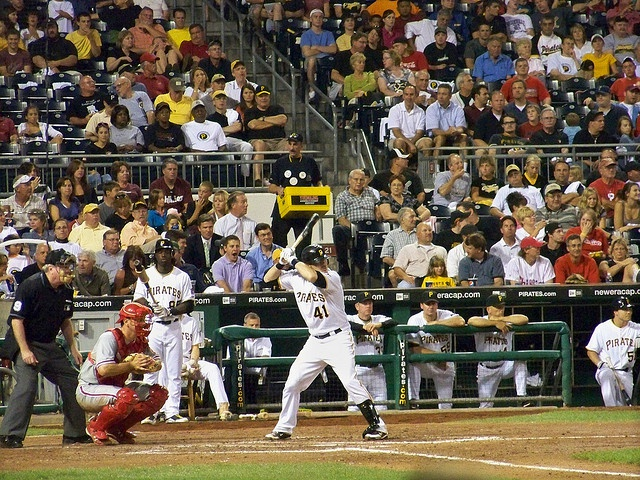Describe the objects in this image and their specific colors. I can see people in black, gray, and maroon tones, people in black and gray tones, people in black, white, darkgray, and gray tones, people in black, white, darkgray, and gray tones, and people in black, gray, darkgray, and lavender tones in this image. 